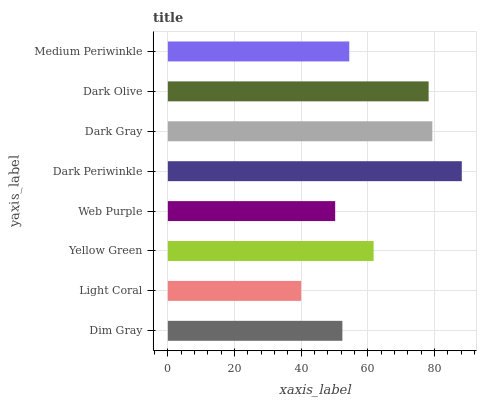Is Light Coral the minimum?
Answer yes or no. Yes. Is Dark Periwinkle the maximum?
Answer yes or no. Yes. Is Yellow Green the minimum?
Answer yes or no. No. Is Yellow Green the maximum?
Answer yes or no. No. Is Yellow Green greater than Light Coral?
Answer yes or no. Yes. Is Light Coral less than Yellow Green?
Answer yes or no. Yes. Is Light Coral greater than Yellow Green?
Answer yes or no. No. Is Yellow Green less than Light Coral?
Answer yes or no. No. Is Yellow Green the high median?
Answer yes or no. Yes. Is Medium Periwinkle the low median?
Answer yes or no. Yes. Is Dim Gray the high median?
Answer yes or no. No. Is Yellow Green the low median?
Answer yes or no. No. 